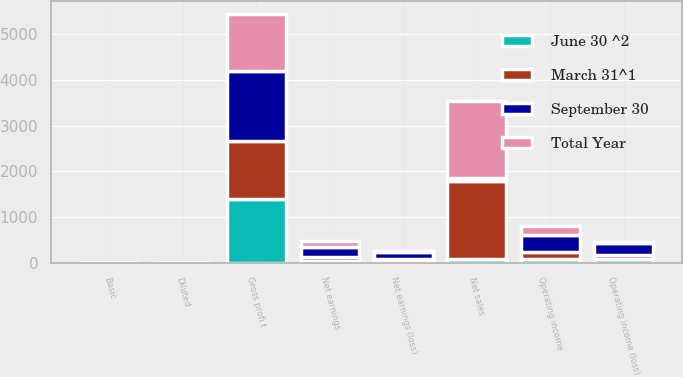Convert chart. <chart><loc_0><loc_0><loc_500><loc_500><stacked_bar_chart><ecel><fcel>Net sales<fcel>Gross profi t<fcel>Operating income (loss)<fcel>Net earnings (loss)<fcel>Basic<fcel>Diluted<fcel>Operating income<fcel>Net earnings<nl><fcel>June 30 ^2<fcel>84<fcel>1403.4<fcel>92.5<fcel>51.1<fcel>0.26<fcel>0.26<fcel>77.9<fcel>39.1<nl><fcel>September 30<fcel>84<fcel>1533<fcel>270.3<fcel>158<fcel>0.8<fcel>0.8<fcel>370.5<fcel>224.4<nl><fcel>March 31^1<fcel>1696.5<fcel>1250.1<fcel>70.3<fcel>27.2<fcel>0.14<fcel>0.14<fcel>161.2<fcel>90.1<nl><fcel>Total Year<fcel>1682.8<fcel>1255.7<fcel>14.7<fcel>17.9<fcel>0.09<fcel>0.09<fcel>201.1<fcel>120.2<nl></chart> 